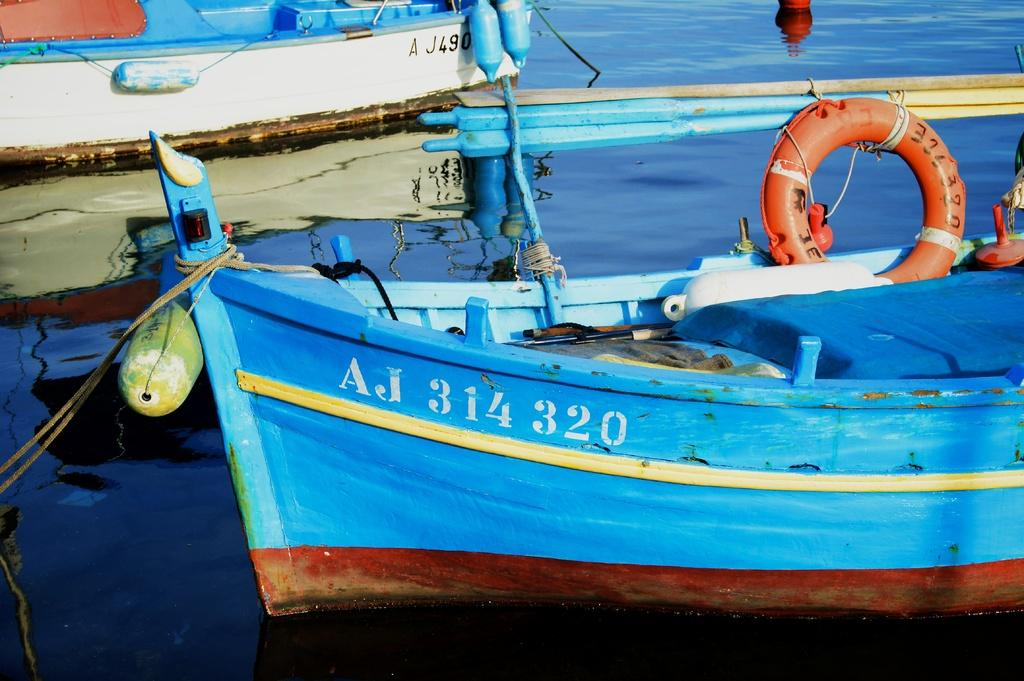Provide a one-sentence caption for the provided image. Blue boat which says AJ314320 on the front. 